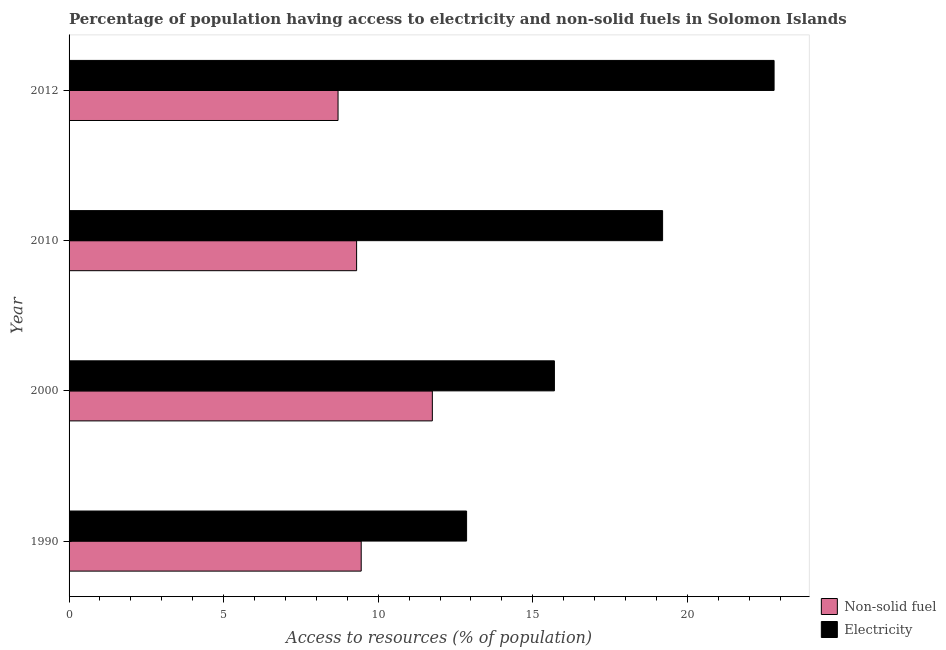How many different coloured bars are there?
Offer a terse response. 2. Are the number of bars on each tick of the Y-axis equal?
Give a very brief answer. Yes. How many bars are there on the 1st tick from the bottom?
Keep it short and to the point. 2. In how many cases, is the number of bars for a given year not equal to the number of legend labels?
Ensure brevity in your answer.  0. What is the percentage of population having access to electricity in 2012?
Give a very brief answer. 22.81. Across all years, what is the maximum percentage of population having access to electricity?
Your answer should be compact. 22.81. Across all years, what is the minimum percentage of population having access to non-solid fuel?
Your response must be concise. 8.7. In which year was the percentage of population having access to electricity maximum?
Your answer should be very brief. 2012. In which year was the percentage of population having access to electricity minimum?
Keep it short and to the point. 1990. What is the total percentage of population having access to electricity in the graph?
Give a very brief answer. 70.57. What is the difference between the percentage of population having access to electricity in 2010 and that in 2012?
Offer a very short reply. -3.61. What is the difference between the percentage of population having access to electricity in 2000 and the percentage of population having access to non-solid fuel in 2012?
Offer a terse response. 7. What is the average percentage of population having access to electricity per year?
Give a very brief answer. 17.64. In the year 1990, what is the difference between the percentage of population having access to electricity and percentage of population having access to non-solid fuel?
Offer a terse response. 3.41. In how many years, is the percentage of population having access to non-solid fuel greater than 22 %?
Make the answer very short. 0. What is the ratio of the percentage of population having access to non-solid fuel in 1990 to that in 2012?
Your answer should be very brief. 1.09. Is the percentage of population having access to electricity in 1990 less than that in 2010?
Give a very brief answer. Yes. Is the difference between the percentage of population having access to electricity in 2010 and 2012 greater than the difference between the percentage of population having access to non-solid fuel in 2010 and 2012?
Give a very brief answer. No. What is the difference between the highest and the second highest percentage of population having access to electricity?
Keep it short and to the point. 3.61. What is the difference between the highest and the lowest percentage of population having access to non-solid fuel?
Your response must be concise. 3.05. In how many years, is the percentage of population having access to non-solid fuel greater than the average percentage of population having access to non-solid fuel taken over all years?
Your answer should be very brief. 1. What does the 2nd bar from the top in 2010 represents?
Make the answer very short. Non-solid fuel. What does the 2nd bar from the bottom in 2010 represents?
Keep it short and to the point. Electricity. How many bars are there?
Your answer should be very brief. 8. What is the difference between two consecutive major ticks on the X-axis?
Make the answer very short. 5. Are the values on the major ticks of X-axis written in scientific E-notation?
Offer a very short reply. No. Does the graph contain grids?
Ensure brevity in your answer.  No. Where does the legend appear in the graph?
Offer a very short reply. Bottom right. How are the legend labels stacked?
Provide a short and direct response. Vertical. What is the title of the graph?
Offer a terse response. Percentage of population having access to electricity and non-solid fuels in Solomon Islands. What is the label or title of the X-axis?
Ensure brevity in your answer.  Access to resources (% of population). What is the Access to resources (% of population) in Non-solid fuel in 1990?
Give a very brief answer. 9.45. What is the Access to resources (% of population) in Electricity in 1990?
Offer a very short reply. 12.86. What is the Access to resources (% of population) of Non-solid fuel in 2000?
Make the answer very short. 11.75. What is the Access to resources (% of population) in Electricity in 2000?
Ensure brevity in your answer.  15.7. What is the Access to resources (% of population) in Non-solid fuel in 2010?
Your answer should be compact. 9.3. What is the Access to resources (% of population) in Non-solid fuel in 2012?
Give a very brief answer. 8.7. What is the Access to resources (% of population) of Electricity in 2012?
Offer a very short reply. 22.81. Across all years, what is the maximum Access to resources (% of population) of Non-solid fuel?
Keep it short and to the point. 11.75. Across all years, what is the maximum Access to resources (% of population) in Electricity?
Give a very brief answer. 22.81. Across all years, what is the minimum Access to resources (% of population) of Non-solid fuel?
Give a very brief answer. 8.7. Across all years, what is the minimum Access to resources (% of population) of Electricity?
Your answer should be compact. 12.86. What is the total Access to resources (% of population) of Non-solid fuel in the graph?
Make the answer very short. 39.2. What is the total Access to resources (% of population) of Electricity in the graph?
Make the answer very short. 70.57. What is the difference between the Access to resources (% of population) in Non-solid fuel in 1990 and that in 2000?
Offer a terse response. -2.3. What is the difference between the Access to resources (% of population) in Electricity in 1990 and that in 2000?
Offer a very short reply. -2.84. What is the difference between the Access to resources (% of population) of Non-solid fuel in 1990 and that in 2010?
Give a very brief answer. 0.15. What is the difference between the Access to resources (% of population) of Electricity in 1990 and that in 2010?
Ensure brevity in your answer.  -6.34. What is the difference between the Access to resources (% of population) of Non-solid fuel in 1990 and that in 2012?
Give a very brief answer. 0.75. What is the difference between the Access to resources (% of population) in Electricity in 1990 and that in 2012?
Ensure brevity in your answer.  -9.95. What is the difference between the Access to resources (% of population) in Non-solid fuel in 2000 and that in 2010?
Provide a succinct answer. 2.45. What is the difference between the Access to resources (% of population) in Electricity in 2000 and that in 2010?
Make the answer very short. -3.5. What is the difference between the Access to resources (% of population) of Non-solid fuel in 2000 and that in 2012?
Ensure brevity in your answer.  3.05. What is the difference between the Access to resources (% of population) of Electricity in 2000 and that in 2012?
Provide a short and direct response. -7.11. What is the difference between the Access to resources (% of population) in Non-solid fuel in 2010 and that in 2012?
Your answer should be very brief. 0.6. What is the difference between the Access to resources (% of population) of Electricity in 2010 and that in 2012?
Give a very brief answer. -3.61. What is the difference between the Access to resources (% of population) of Non-solid fuel in 1990 and the Access to resources (% of population) of Electricity in 2000?
Offer a very short reply. -6.25. What is the difference between the Access to resources (% of population) of Non-solid fuel in 1990 and the Access to resources (% of population) of Electricity in 2010?
Keep it short and to the point. -9.75. What is the difference between the Access to resources (% of population) of Non-solid fuel in 1990 and the Access to resources (% of population) of Electricity in 2012?
Make the answer very short. -13.36. What is the difference between the Access to resources (% of population) of Non-solid fuel in 2000 and the Access to resources (% of population) of Electricity in 2010?
Offer a terse response. -7.45. What is the difference between the Access to resources (% of population) in Non-solid fuel in 2000 and the Access to resources (% of population) in Electricity in 2012?
Keep it short and to the point. -11.05. What is the difference between the Access to resources (% of population) in Non-solid fuel in 2010 and the Access to resources (% of population) in Electricity in 2012?
Make the answer very short. -13.5. What is the average Access to resources (% of population) of Non-solid fuel per year?
Make the answer very short. 9.8. What is the average Access to resources (% of population) of Electricity per year?
Ensure brevity in your answer.  17.64. In the year 1990, what is the difference between the Access to resources (% of population) in Non-solid fuel and Access to resources (% of population) in Electricity?
Your answer should be compact. -3.41. In the year 2000, what is the difference between the Access to resources (% of population) in Non-solid fuel and Access to resources (% of population) in Electricity?
Provide a succinct answer. -3.95. In the year 2010, what is the difference between the Access to resources (% of population) of Non-solid fuel and Access to resources (% of population) of Electricity?
Make the answer very short. -9.9. In the year 2012, what is the difference between the Access to resources (% of population) in Non-solid fuel and Access to resources (% of population) in Electricity?
Offer a terse response. -14.11. What is the ratio of the Access to resources (% of population) of Non-solid fuel in 1990 to that in 2000?
Provide a short and direct response. 0.8. What is the ratio of the Access to resources (% of population) in Electricity in 1990 to that in 2000?
Offer a terse response. 0.82. What is the ratio of the Access to resources (% of population) in Non-solid fuel in 1990 to that in 2010?
Provide a succinct answer. 1.02. What is the ratio of the Access to resources (% of population) of Electricity in 1990 to that in 2010?
Provide a short and direct response. 0.67. What is the ratio of the Access to resources (% of population) in Non-solid fuel in 1990 to that in 2012?
Make the answer very short. 1.09. What is the ratio of the Access to resources (% of population) of Electricity in 1990 to that in 2012?
Make the answer very short. 0.56. What is the ratio of the Access to resources (% of population) of Non-solid fuel in 2000 to that in 2010?
Offer a terse response. 1.26. What is the ratio of the Access to resources (% of population) in Electricity in 2000 to that in 2010?
Give a very brief answer. 0.82. What is the ratio of the Access to resources (% of population) in Non-solid fuel in 2000 to that in 2012?
Give a very brief answer. 1.35. What is the ratio of the Access to resources (% of population) in Electricity in 2000 to that in 2012?
Your answer should be compact. 0.69. What is the ratio of the Access to resources (% of population) of Non-solid fuel in 2010 to that in 2012?
Your answer should be very brief. 1.07. What is the ratio of the Access to resources (% of population) of Electricity in 2010 to that in 2012?
Your answer should be compact. 0.84. What is the difference between the highest and the second highest Access to resources (% of population) of Non-solid fuel?
Your response must be concise. 2.3. What is the difference between the highest and the second highest Access to resources (% of population) of Electricity?
Provide a succinct answer. 3.61. What is the difference between the highest and the lowest Access to resources (% of population) of Non-solid fuel?
Keep it short and to the point. 3.05. What is the difference between the highest and the lowest Access to resources (% of population) in Electricity?
Provide a succinct answer. 9.95. 